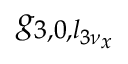<formula> <loc_0><loc_0><loc_500><loc_500>g _ { 3 , 0 , l _ { 3 \nu _ { x } } }</formula> 